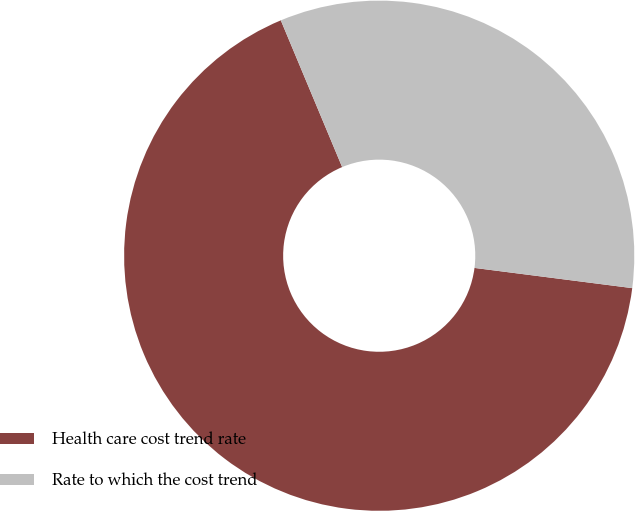<chart> <loc_0><loc_0><loc_500><loc_500><pie_chart><fcel>Health care cost trend rate<fcel>Rate to which the cost trend<nl><fcel>66.67%<fcel>33.33%<nl></chart> 